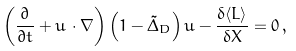Convert formula to latex. <formula><loc_0><loc_0><loc_500><loc_500>\left ( \frac { \partial } { \partial t } + u \, \cdot \nabla \right ) \left ( 1 - \tilde { \Delta } _ { D } \right ) u - \frac { \delta \langle L \rangle } { \delta X } = 0 \, ,</formula> 